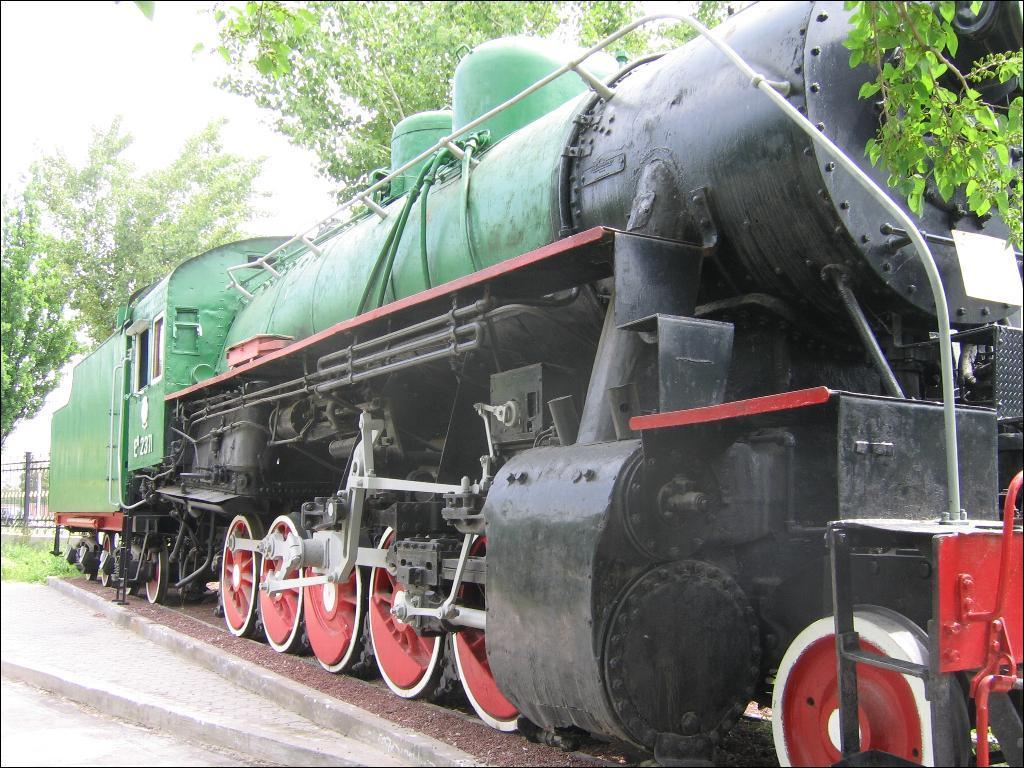What is the main subject on the right side of the image? There is a train engine on the right side of the image. What can be seen in the background of the image? There are trees in the background of the image. What part of the sky is visible in the image? The sky is visible at the left top of the image. What type of distribution system is being used by the train engine in the image? There is no information about a distribution system in the image, as it only shows a train engine and trees in the background. 